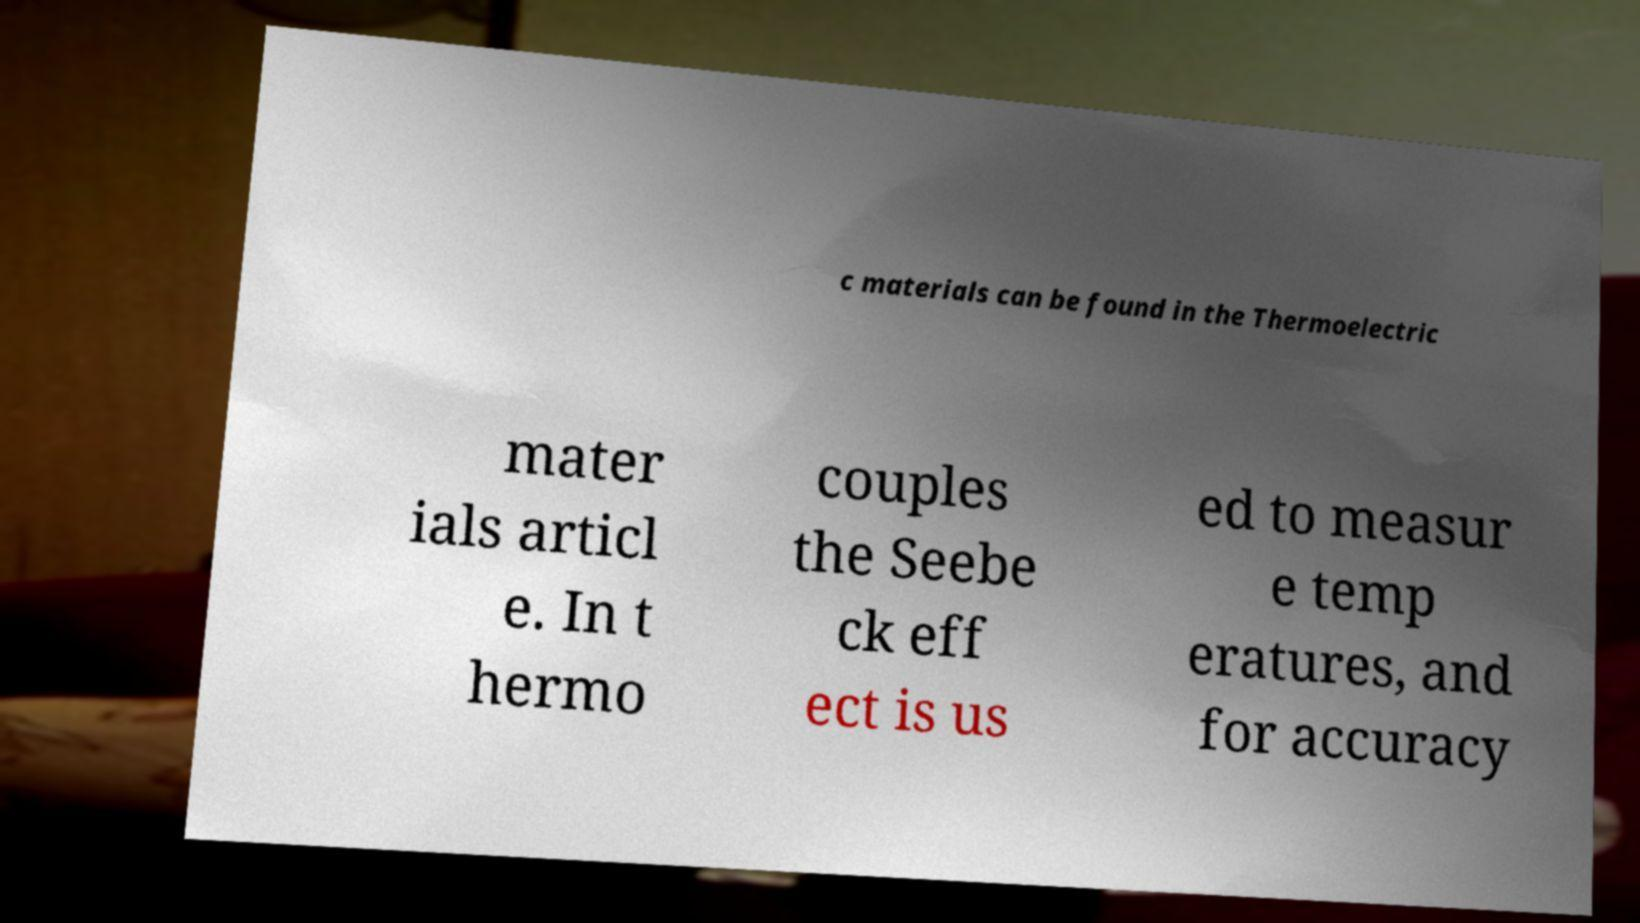For documentation purposes, I need the text within this image transcribed. Could you provide that? c materials can be found in the Thermoelectric mater ials articl e. In t hermo couples the Seebe ck eff ect is us ed to measur e temp eratures, and for accuracy 